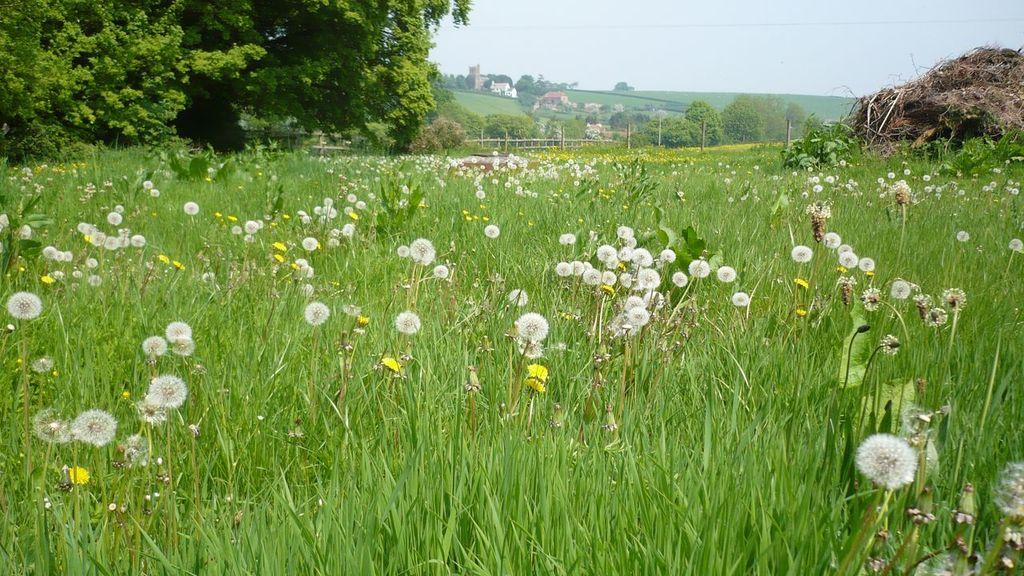What type of vegetation can be seen in the image? There are flowers, plants, and trees in the image. What type of barrier is present in the image? There is fencing in the image. What type of elevated land feature is present in the image? There is a hill in the image. What type of structures can be seen in the image? There are buildings and houses in the image. What part of the natural environment is visible in the image? The sky is visible in the image. How many children are playing on the hill in the image? There are no children present in the image; it features flowers, plants, trees, fencing, a hill, buildings, houses, and the sky. Can you describe the toad that is sitting on the roof of the house in the image? There is no toad present in the image; it features flowers, plants, trees, fencing, a hill, buildings, houses, and the sky. 